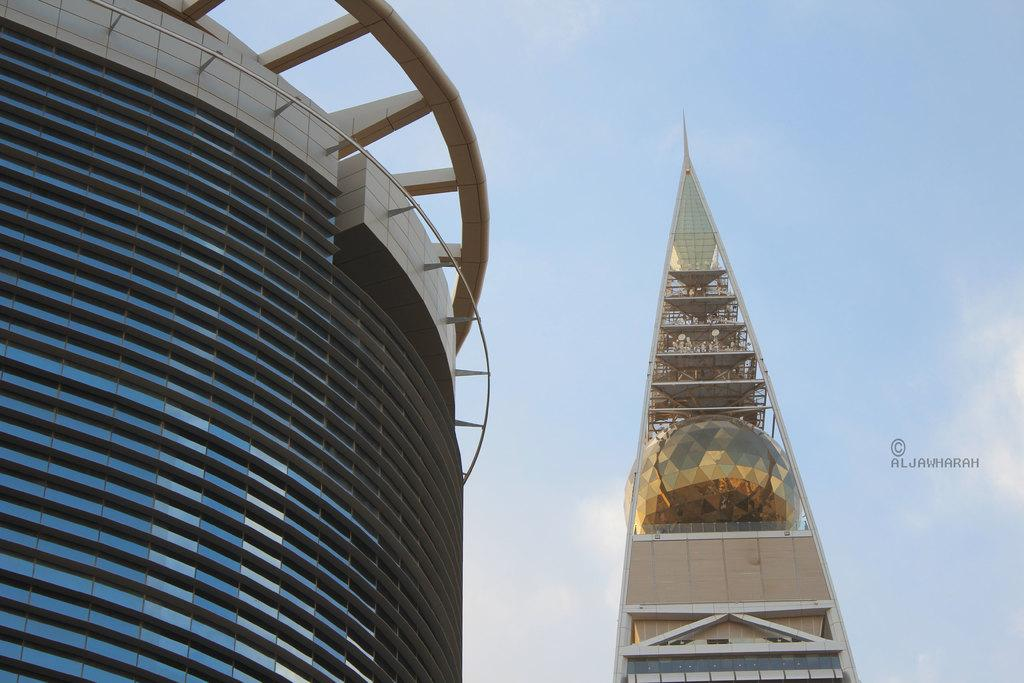How many buildings can be seen in the image? There are two buildings in the image. What is visible at the top of the image? The sky is visible at the top of the image. What type of frog can be seen sitting on the roof of one of the buildings in the image? There is no frog present in the image; it only features two buildings and the sky. 